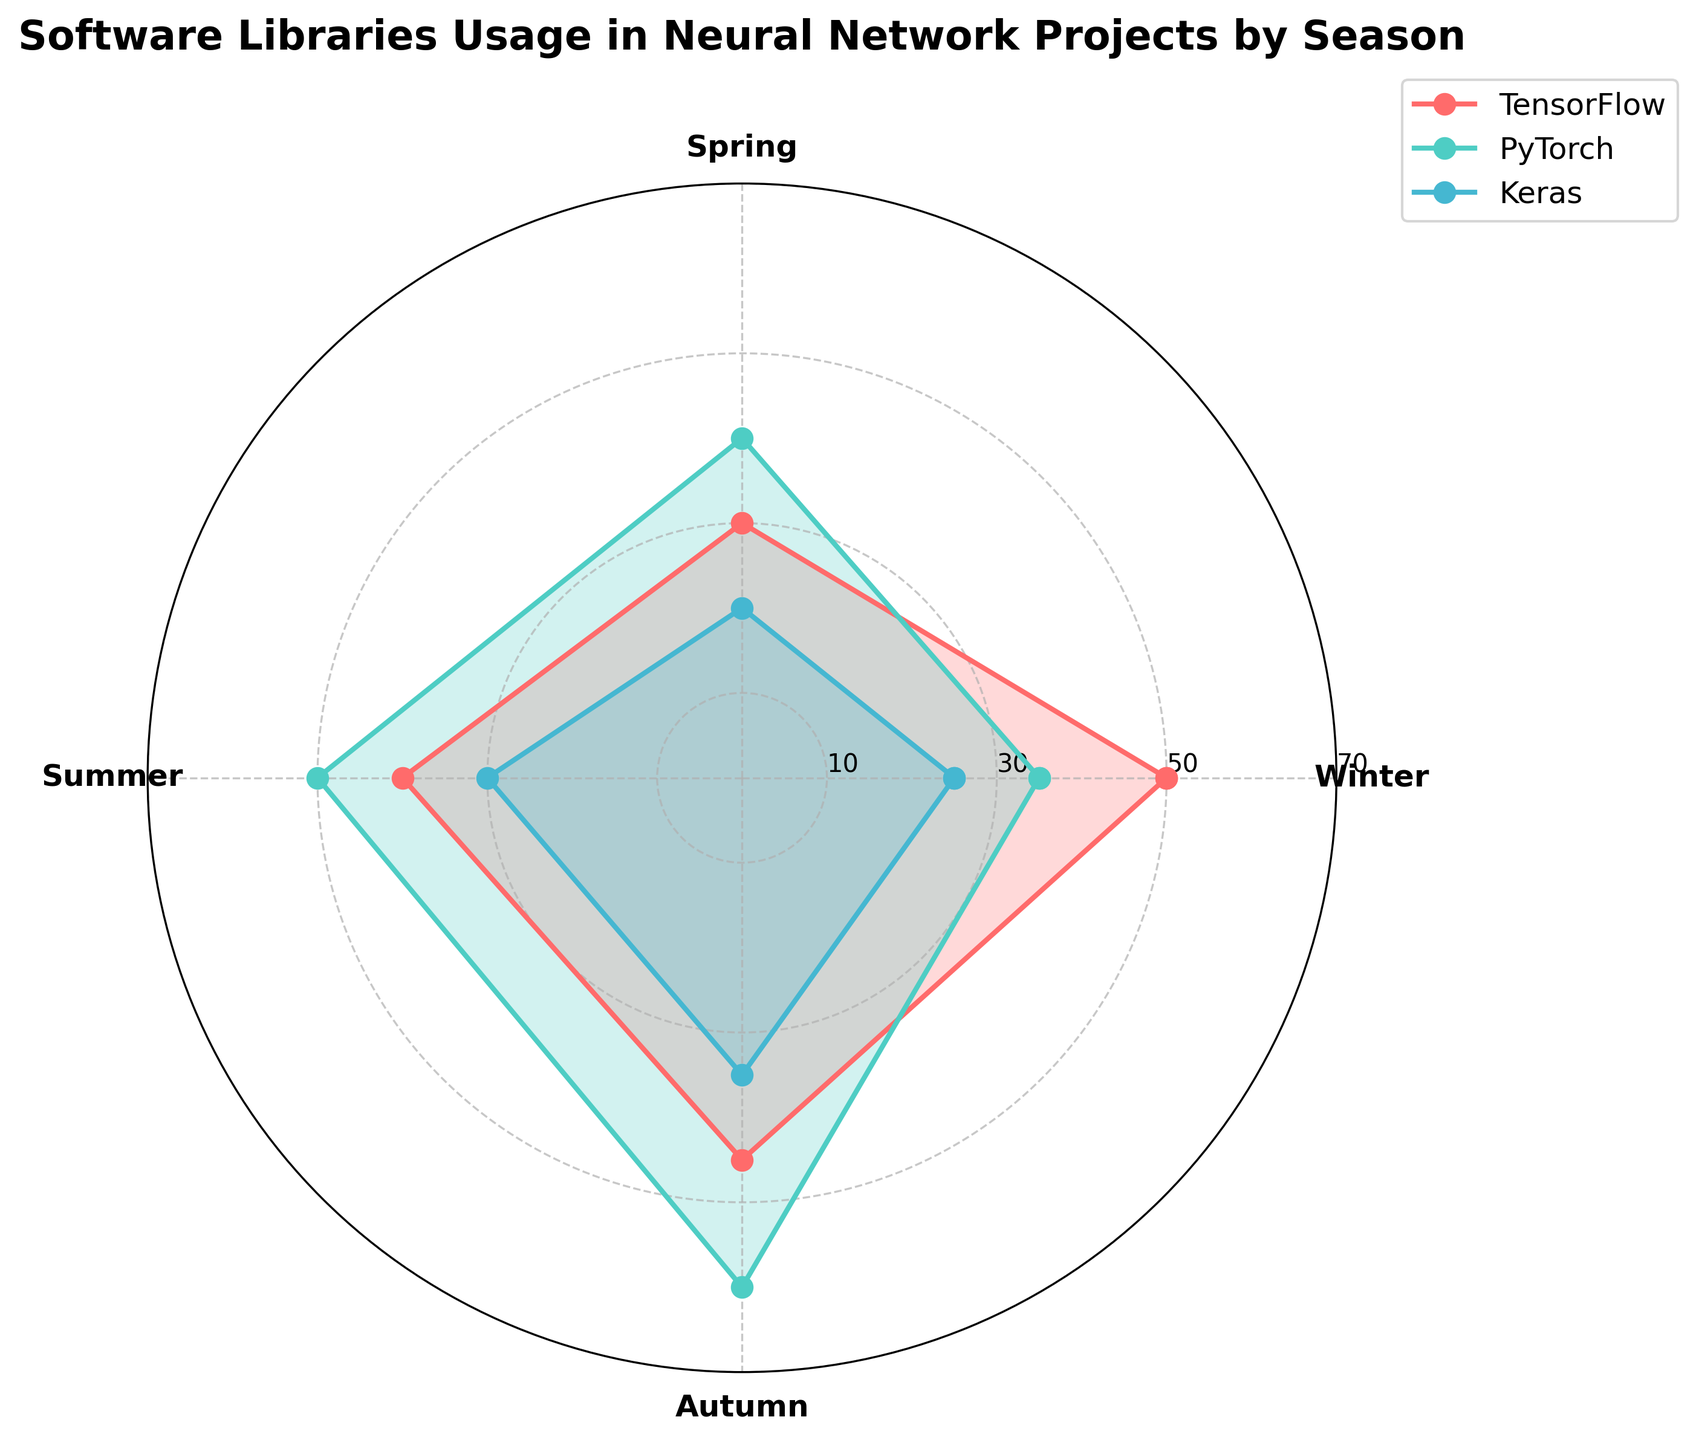Which season has the highest usage of PyTorch? In the chart, the outermost points of the PyTorch (usually in one distinct color) polygon indicate the highest usage value. Check which season corresponds to this outermost point.
Answer: Autumn Which library has the lowest usage in Winter? By looking at the lengths of the radial bars in Winter for each library, observe the shortest bar. The library associated with this bar has the lowest usage.
Answer: Keras What is the overall trend of TensorFlow usage across the seasons? Observe the shape and size of the TensorFlow polygon across the four seasons. Determine if it generally increases, decreases, or fluctuates. TensorFlow usage decreases from Winter to Spring, then increases from Spring through Autumn.
Answer: Decreases then increases How does the usage of Keras in Spring compare with its usage in Autumn? Compare the lengths of the radial bars for Keras in Spring and Autumn. Notice the height difference to understand the variation in usage.
Answer: Autumn is higher than Spring Which season has the most even usage across all three libraries? Look for the season where all three library points (markers) are as close to each other as possible, indicating similar usage levels.
Answer: Winter What is the difference in usage between TensorFlow and PyTorch in Summer? Identify the points representing TensorFlow and PyTorch in Summer, and calculate the difference.
Answer: 10 Is there any season where Keras usage surpasses TensorFlow usage? Compare the heights of the radial bars representing Keras and TensorFlow for each season to see if Keras is ever higher than TensorFlow.
Answer: No What is the total usage of PyTorch over all seasons? Add the values of PyTorch usage across Winter, Spring, Summer, and Autumn to get the total usage.
Answer: 185 